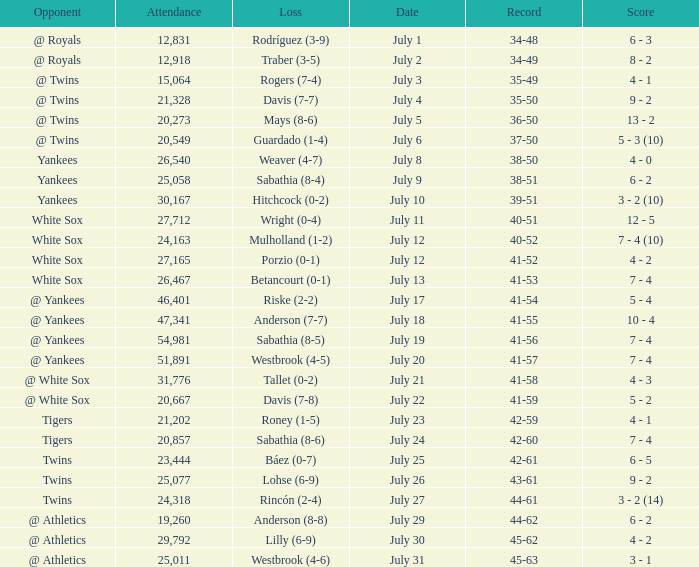Which Record has an Opponent of twins, and a Date of july 25? 42-61. 